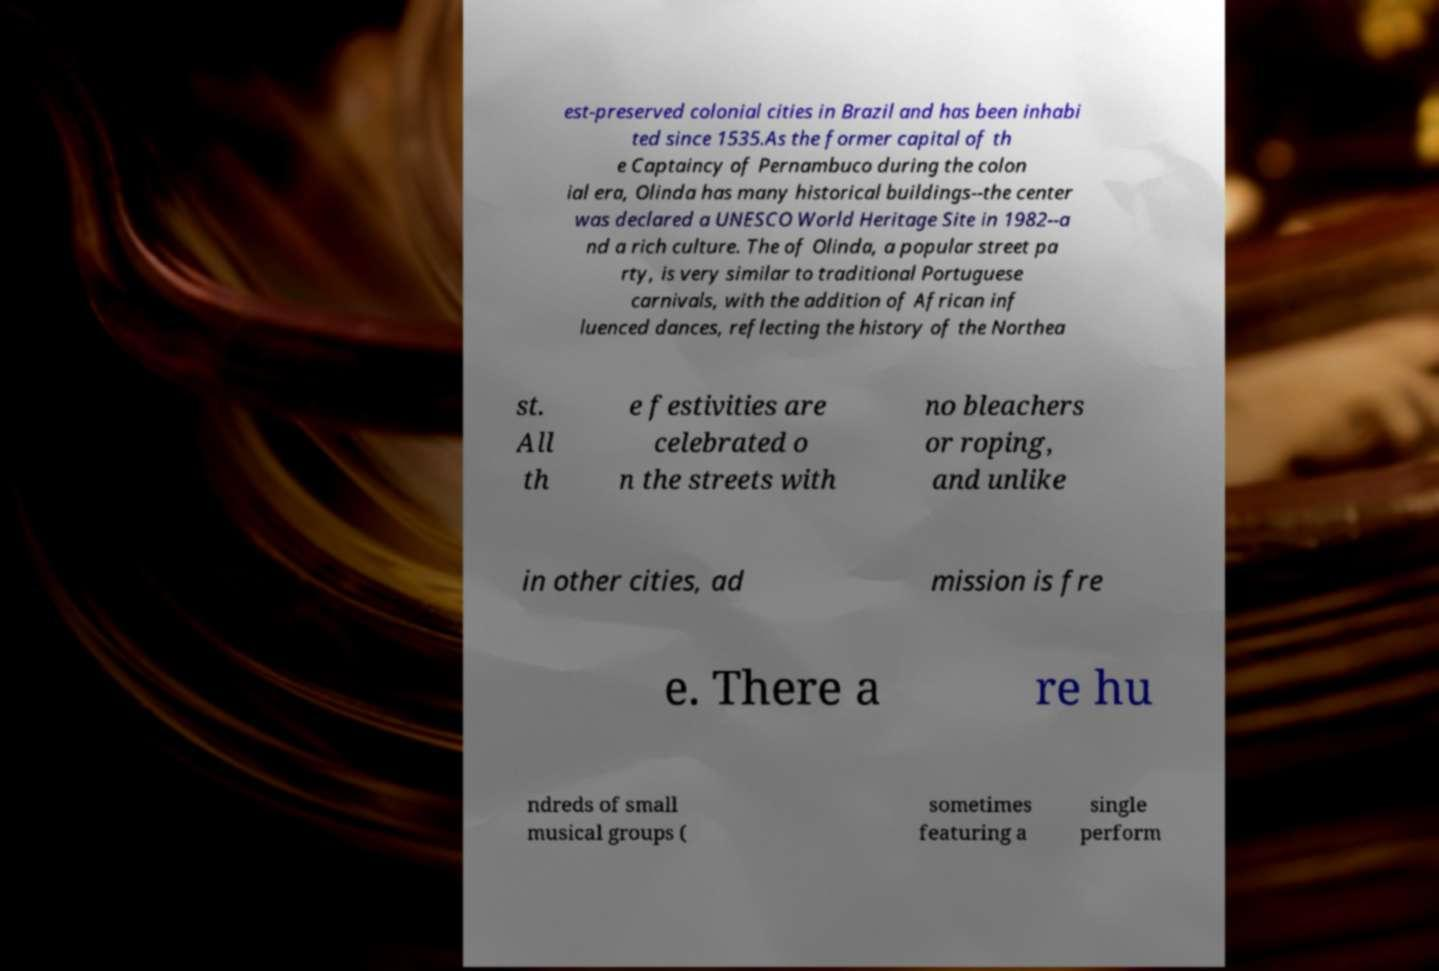I need the written content from this picture converted into text. Can you do that? est-preserved colonial cities in Brazil and has been inhabi ted since 1535.As the former capital of th e Captaincy of Pernambuco during the colon ial era, Olinda has many historical buildings--the center was declared a UNESCO World Heritage Site in 1982--a nd a rich culture. The of Olinda, a popular street pa rty, is very similar to traditional Portuguese carnivals, with the addition of African inf luenced dances, reflecting the history of the Northea st. All th e festivities are celebrated o n the streets with no bleachers or roping, and unlike in other cities, ad mission is fre e. There a re hu ndreds of small musical groups ( sometimes featuring a single perform 